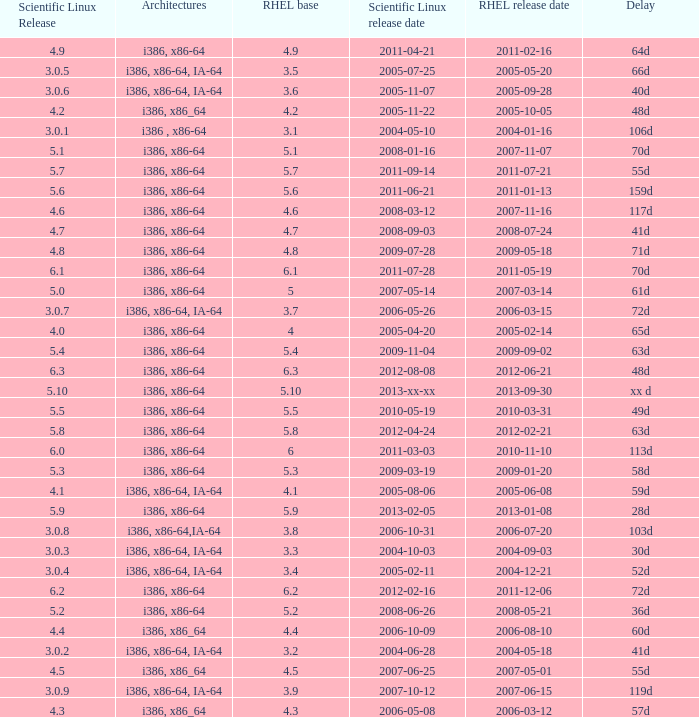When is the rhel launch date when scientific linux release is 2004-12-21. 